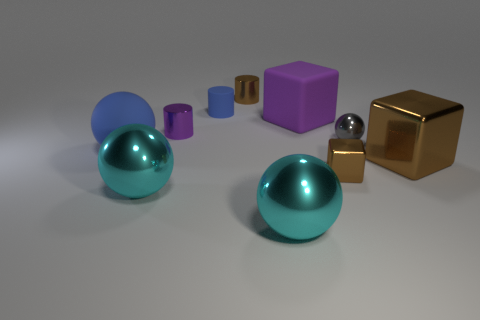Subtract all large purple matte blocks. How many blocks are left? 2 Subtract all yellow cylinders. How many cyan balls are left? 2 Subtract all gray spheres. How many spheres are left? 3 Subtract 1 balls. How many balls are left? 3 Subtract all spheres. How many objects are left? 6 Subtract all blue blocks. Subtract all green cylinders. How many blocks are left? 3 Subtract 0 green cylinders. How many objects are left? 10 Subtract all tiny purple blocks. Subtract all metallic cubes. How many objects are left? 8 Add 2 big purple matte cubes. How many big purple matte cubes are left? 3 Add 8 big gray rubber blocks. How many big gray rubber blocks exist? 8 